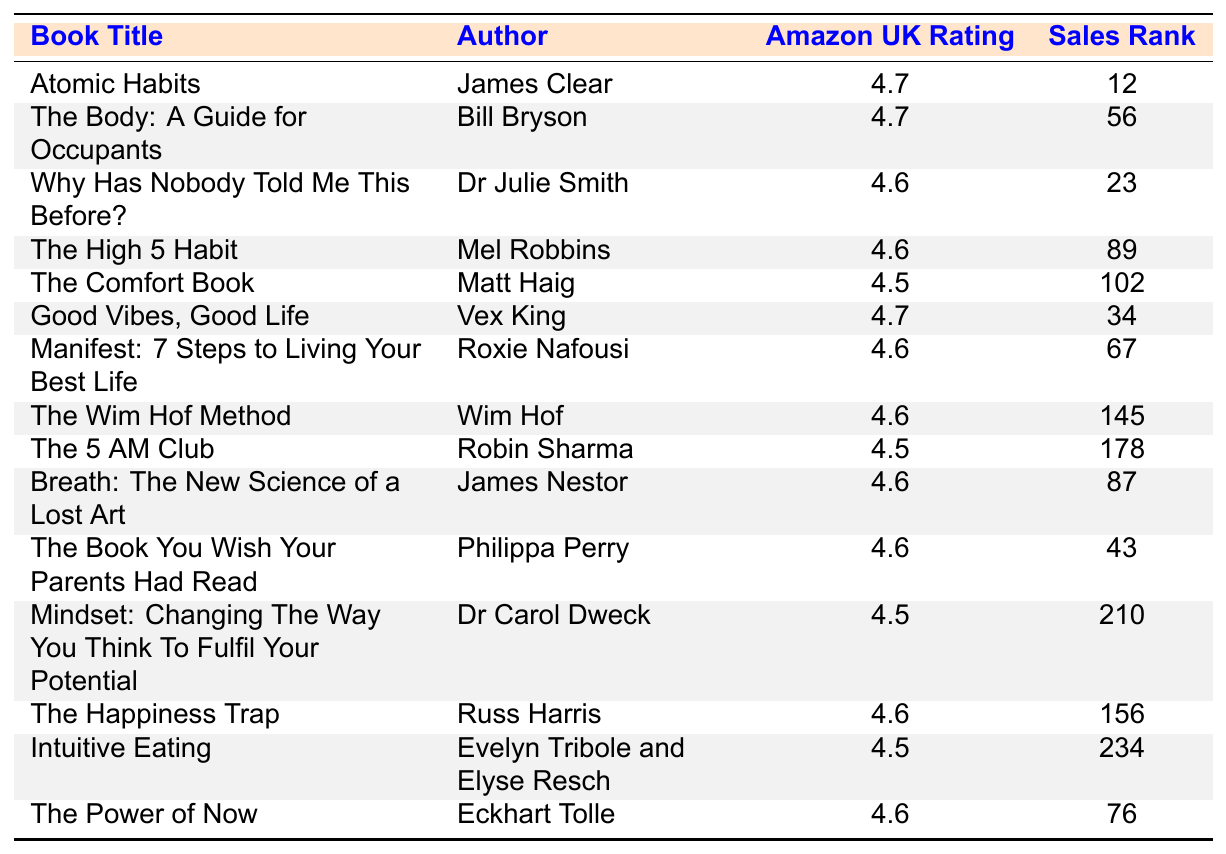What is the highest Amazon UK rating among the listed books? The table shows the Amazon UK ratings for each book. By looking through the ratings, both "Atomic Habits" and "Good Vibes, Good Life" have the highest rating of 4.7.
Answer: 4.7 Which book is ranked the lowest in sales? The sales rank indicates the position of each book based on sales, where a lower number means higher sales. According to the table, "Intuitive Eating" has the highest sales rank of 234, making it the lowest ranked book.
Answer: Intuitive Eating Who is the author of "The Comfort Book"? The table lists the authors next to their respective book titles. "The Comfort Book" corresponds to the author Matt Haig.
Answer: Matt Haig Are there any books with an Amazon UK rating of 4.5? I can check the ratings in the table, where "The Comfort Book," "The 5 AM Club," "Mindset," and "Intuitive Eating" all have a rating of 4.5. Therefore, there are books with this rating.
Answer: Yes What is the average rating of all books listed in the table? To find the average, I sum all the ratings (4.7 + 4.7 + 4.6 + 4.6 + 4.5 + 4.7 + 4.6 + 4.6 + 4.5 + 4.6 + 4.6 + 4.5 + 4.6 + 4.6 + 4.5) which equals 69. It is then divided by the total number of books (15), resulting in an average rating of 4.6.
Answer: 4.6 Which books have a higher rating than 4.5 and a sales rank under 100? The books in this category are "Atomic Habits," "Good Vibes, Good Life," "Why Has Nobody Told Me This Before?", "The High 5 Habit," and "Breath." All these have ratings above 4.5 and sales ranks under 100.
Answer: Atomic Habits, Good Vibes, Good Life, Why Has Nobody Told Me This Before?, The High 5 Habit, Breath What percentage of the books have an Amazon UK rating of 4.6? There are 8 books with a rating of 4.6 out of a total of 15 books. To find the percentage, I calculate (8/15) * 100 which gives approximately 53.33%.
Answer: 53.33% Which book by Bill Bryson is included in the table? The table features "The Body: A Guide for Occupants" as the book authored by Bill Bryson.
Answer: The Body: A Guide for Occupants Is there a book in the table written by Eckhart Tolle? By checking the author column in the table, "The Power of Now" is indeed written by Eckhart Tolle, confirming the presence of this book.
Answer: Yes What is the difference in sales rank between "Atomic Habits" and "The 5 AM Club"? The sales rank for "Atomic Habits" is 12 and for "The 5 AM Club" it is 178. The difference is calculated as 178 - 12 = 166.
Answer: 166 Which author has the most books listed in the table? I need to count the occurrences of each author's books. Each listed author appears once, making none have multiple titles, so there's no author with the most books as they all have one.
Answer: None 